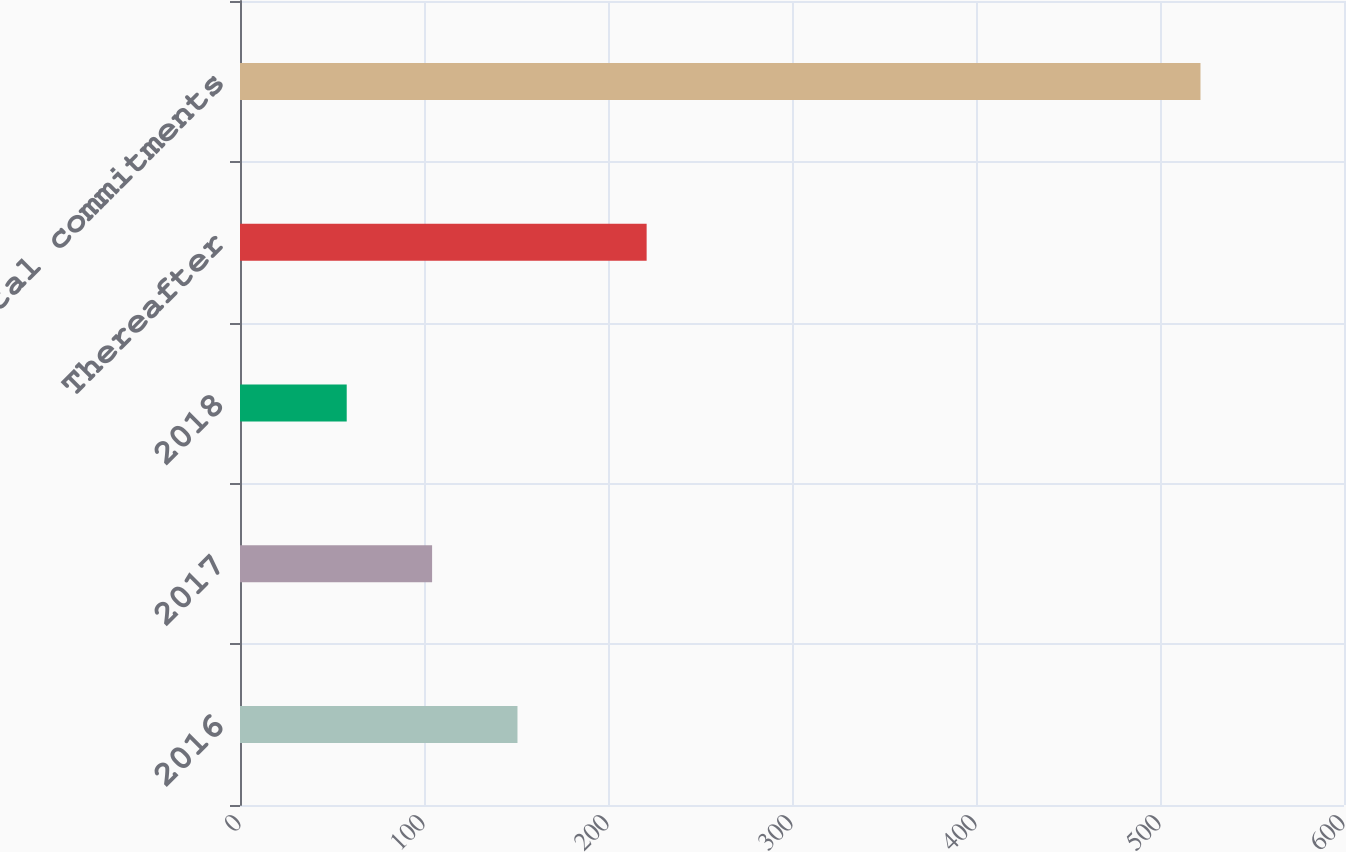Convert chart to OTSL. <chart><loc_0><loc_0><loc_500><loc_500><bar_chart><fcel>2016<fcel>2017<fcel>2018<fcel>Thereafter<fcel>Total commitments<nl><fcel>150.8<fcel>104.4<fcel>58<fcel>221<fcel>522<nl></chart> 